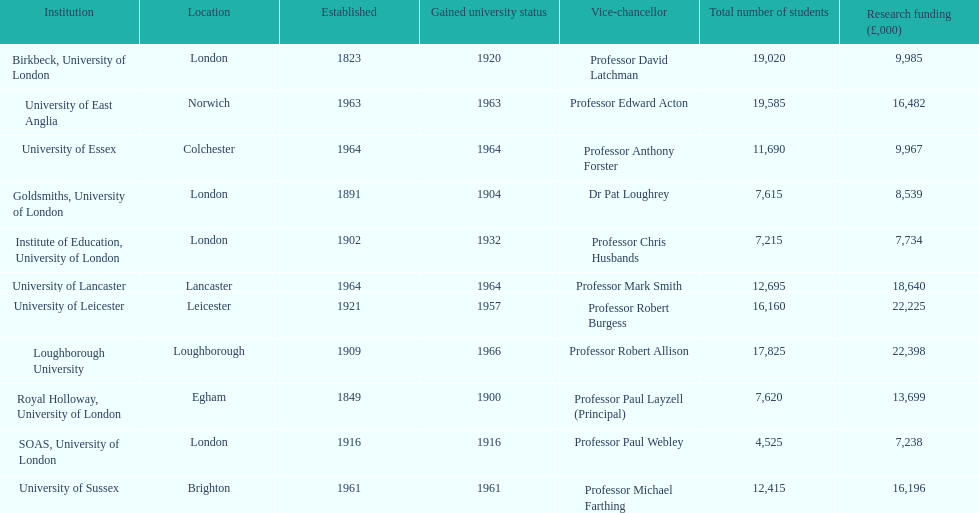Which institution has the most research funding? Loughborough University. 